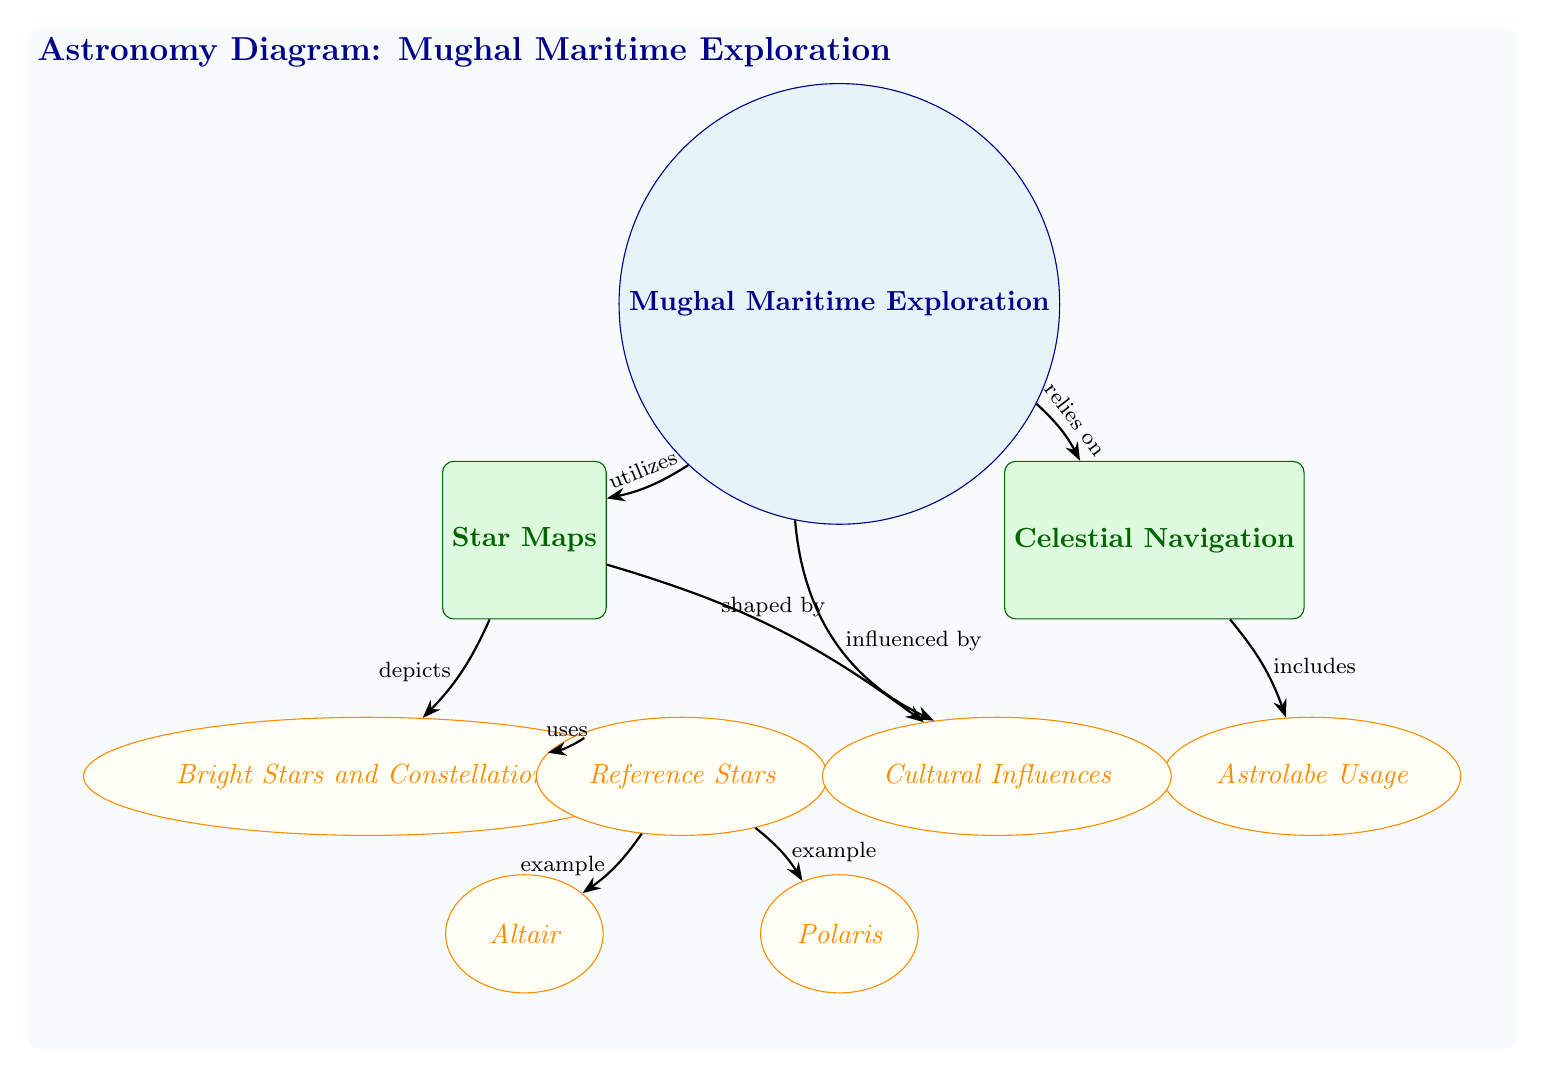What is the main topic of the diagram? The main topic, represented at the top center of the diagram, is "Mughal Maritime Exploration."
Answer: Mughal Maritime Exploration How many nodes are there in the diagram? By counting all the individual shapes (topics, subtopics, and nodes) within the diagram, we find a total of 8 distinct nodes.
Answer: 8 What does "Star Maps" depict in the diagram? The "Star Maps" subtopic, connected to the main topic, shows the specific aspect of Mughal Maritime Exploration related to celestial navigation techniques.
Answer: Bright Stars and Constellations What type of navigation method is included under "Celestial Navigation"? The diagram specifies that "Astrolabe Usage" is included as a method under "Celestial Navigation," indicating its importance in the exploration context.
Answer: Astrolabe Usage Which star is an example of a reference star? The node labeled "Polaris," connected under the "Reference Stars," serves as a notable example of a reference star utilized in navigation.
Answer: Polaris What influences the Mughal Maritime Exploration as shown in the diagram? The diagram illustrates that "Cultural Influences" play a significant role in shaping both "Mughal Maritime Exploration" and "Star Maps."
Answer: Cultural Influences How does "Star Maps" relate to "Celestial Navigation"? The diagram indicates that "Star Maps" depicts essential information utilized by "Celestial Navigation," thus establishing a direct relationship between these two critical aspects.
Answer: depicts What is an example of a bright star given in the diagram? Among the examples listed under "Bright Stars and Constellations," the star "Altair" is explicitly mentioned as a prominent reference point for navigation.
Answer: Altair Which node has the most direct influence on "Star Maps"? The node "Cultural Influences" has a dual connection, impacting both "Star Maps" directly and "Mughal Maritime Exploration," establishing a strong influence.
Answer: Cultural Influences 